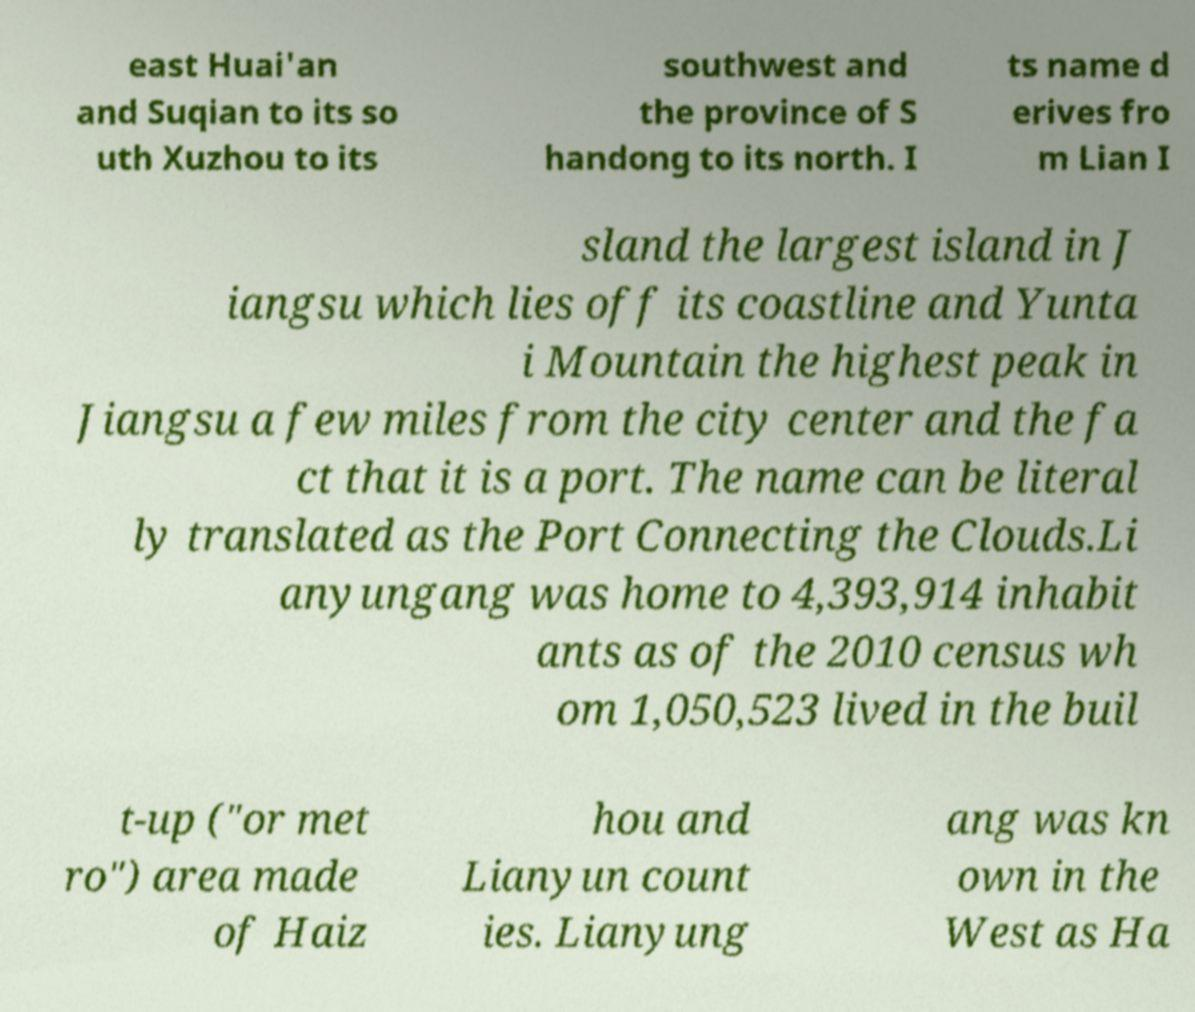I need the written content from this picture converted into text. Can you do that? east Huai'an and Suqian to its so uth Xuzhou to its southwest and the province of S handong to its north. I ts name d erives fro m Lian I sland the largest island in J iangsu which lies off its coastline and Yunta i Mountain the highest peak in Jiangsu a few miles from the city center and the fa ct that it is a port. The name can be literal ly translated as the Port Connecting the Clouds.Li anyungang was home to 4,393,914 inhabit ants as of the 2010 census wh om 1,050,523 lived in the buil t-up ("or met ro") area made of Haiz hou and Lianyun count ies. Lianyung ang was kn own in the West as Ha 